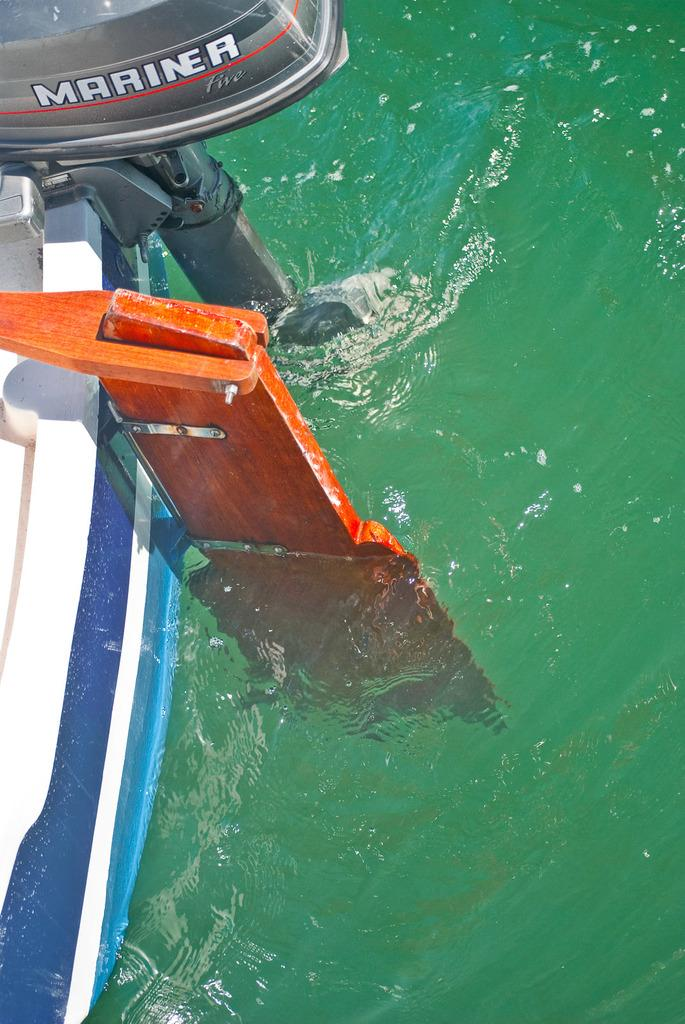What type of water body is visible on the right side of the image? There is an ocean on the right side of the image. What can be seen on the left side of the image? There is a boat on the left side of the image. Where is the jar located in the image? There is no jar present in the image. What type of laborer can be seen working on the boat in the image? There are no laborers or any indication of work being done on the boat in the image. 